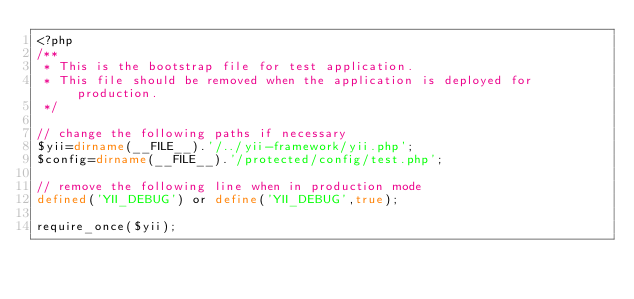Convert code to text. <code><loc_0><loc_0><loc_500><loc_500><_PHP_><?php
/**
 * This is the bootstrap file for test application.
 * This file should be removed when the application is deployed for production.
 */

// change the following paths if necessary
$yii=dirname(__FILE__).'/../yii-framework/yii.php';
$config=dirname(__FILE__).'/protected/config/test.php';

// remove the following line when in production mode
defined('YII_DEBUG') or define('YII_DEBUG',true);

require_once($yii);</code> 